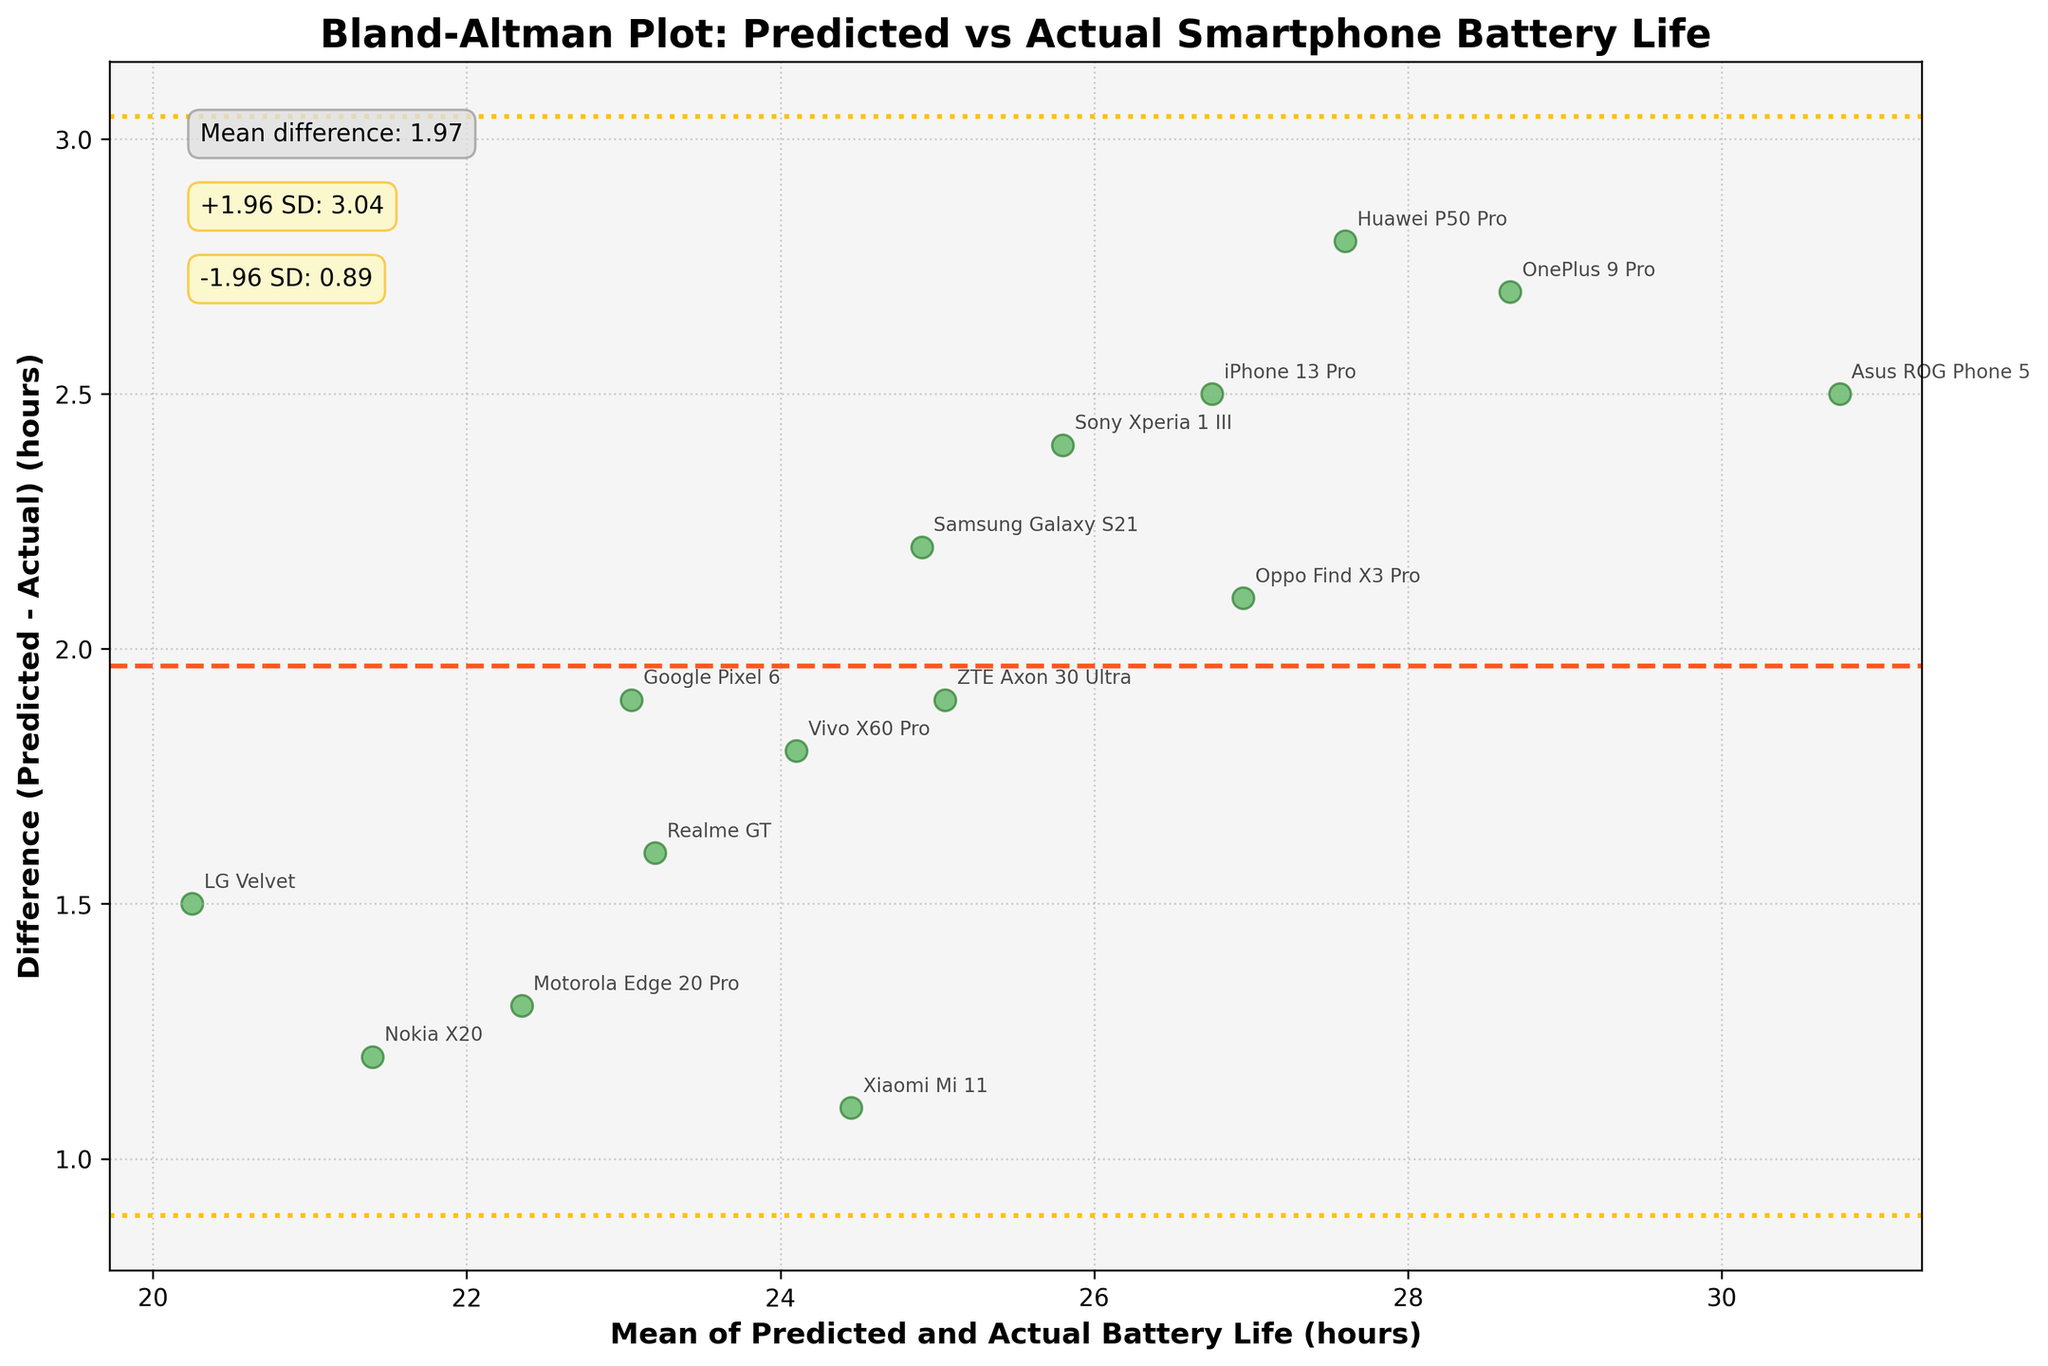How many data points are plotted in the figure? Look at the number of data points annotated. Each smartphone model represents one data point. There are 15 different smartphone models plotted.
Answer: 15 What is the range of the difference between predicted and actual battery life? Check the scatter plot for the y-axis which shows the difference (Predicted - Actual) battery life. The range extends from around 0.5 hours to 2.5 hours.
Answer: 0.5 to 2.5 hours Which smartphone model has the greatest positive discrepancy in predicted versus actual battery life? Look for the highest point on the y-axis where the difference is maximal. The Asus ROG Phone 5 is the highest point with a difference of 2.5 hours.
Answer: Asus ROG Phone 5 What are the mean difference and the limits of agreement shown in the plot? The mean difference is marked by a dashed line and annotated, and the limits of agreement (+1.96 SD and -1.96 SD) are marked by dotted lines and annotated in the plot. The mean difference is approximately 2.02, with the limits of agreement between approximately 1.03 and 3.01.
Answer: Mean difference: 2.02; Limits of agreement: 1.03 to 3.01 Which smartphone model has the smallest discrepancy between predicted and actual battery life? Determine the data point closest to the y-axis value of 0. The Nokia X20 has the smallest positive discrepancy closest to 0.5 hours.
Answer: Nokia X20 What's the mean of the mean battery life for OnePlus 9 Pro and Huawei P50 Pro? Add the mean battery life of OnePlus 9 Pro (28.65) and Huawei P50 Pro (27.6), then divide by 2. (28.65 + 27.6) / 2 = 28.125 hours
Answer: 28.125 hours How many smartphone models have a difference (Predicted - Actual) greater than the mean difference? Based on the plot, count the number of points above the mean difference line (dashed line). There are 8 models above the mean difference line.
Answer: 8 models Which two smartphone models have nearly the same mean battery life? Find overlapping or very close points horizontally (x-axis). Samsung Galaxy S21 and ZTE Axon 30 Ultra have means very close to each other around 24.95 hours.
Answer: Samsung Galaxy S21 and ZTE Axon 30 Ultra Between iPhone 13 Pro and Motorola Edge 20 Pro, which model has a higher discrepancy? Compare their positions on the y-axis where iPhone 13 Pro is higher with a discrepancy of 2.5 hours and Motorola Edge 20 Pro around 1.3 hours.
Answer: iPhone 13 Pro 